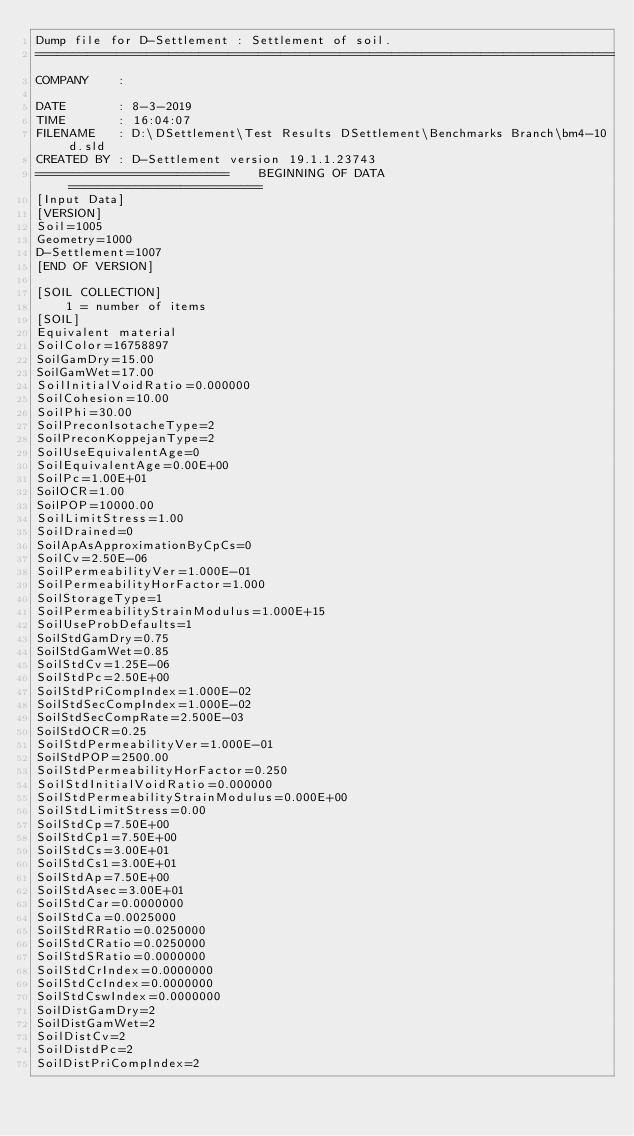<code> <loc_0><loc_0><loc_500><loc_500><_Scheme_>Dump file for D-Settlement : Settlement of soil.
==============================================================================
COMPANY    : 

DATE       : 8-3-2019
TIME       : 16:04:07
FILENAME   : D:\DSettlement\Test Results DSettlement\Benchmarks Branch\bm4-10d.sld
CREATED BY : D-Settlement version 19.1.1.23743
==========================    BEGINNING OF DATA     ==========================
[Input Data]
[VERSION]
Soil=1005
Geometry=1000
D-Settlement=1007
[END OF VERSION]

[SOIL COLLECTION]
    1 = number of items
[SOIL]
Equivalent material
SoilColor=16758897
SoilGamDry=15.00
SoilGamWet=17.00
SoilInitialVoidRatio=0.000000
SoilCohesion=10.00
SoilPhi=30.00
SoilPreconIsotacheType=2
SoilPreconKoppejanType=2
SoilUseEquivalentAge=0
SoilEquivalentAge=0.00E+00
SoilPc=1.00E+01
SoilOCR=1.00
SoilPOP=10000.00
SoilLimitStress=1.00
SoilDrained=0
SoilApAsApproximationByCpCs=0
SoilCv=2.50E-06
SoilPermeabilityVer=1.000E-01
SoilPermeabilityHorFactor=1.000
SoilStorageType=1
SoilPermeabilityStrainModulus=1.000E+15
SoilUseProbDefaults=1
SoilStdGamDry=0.75
SoilStdGamWet=0.85
SoilStdCv=1.25E-06
SoilStdPc=2.50E+00
SoilStdPriCompIndex=1.000E-02
SoilStdSecCompIndex=1.000E-02
SoilStdSecCompRate=2.500E-03
SoilStdOCR=0.25
SoilStdPermeabilityVer=1.000E-01
SoilStdPOP=2500.00
SoilStdPermeabilityHorFactor=0.250
SoilStdInitialVoidRatio=0.000000
SoilStdPermeabilityStrainModulus=0.000E+00
SoilStdLimitStress=0.00
SoilStdCp=7.50E+00
SoilStdCp1=7.50E+00
SoilStdCs=3.00E+01
SoilStdCs1=3.00E+01
SoilStdAp=7.50E+00
SoilStdAsec=3.00E+01
SoilStdCar=0.0000000
SoilStdCa=0.0025000
SoilStdRRatio=0.0250000
SoilStdCRatio=0.0250000
SoilStdSRatio=0.0000000
SoilStdCrIndex=0.0000000
SoilStdCcIndex=0.0000000
SoilStdCswIndex=0.0000000
SoilDistGamDry=2
SoilDistGamWet=2
SoilDistCv=2
SoilDistdPc=2
SoilDistPriCompIndex=2</code> 